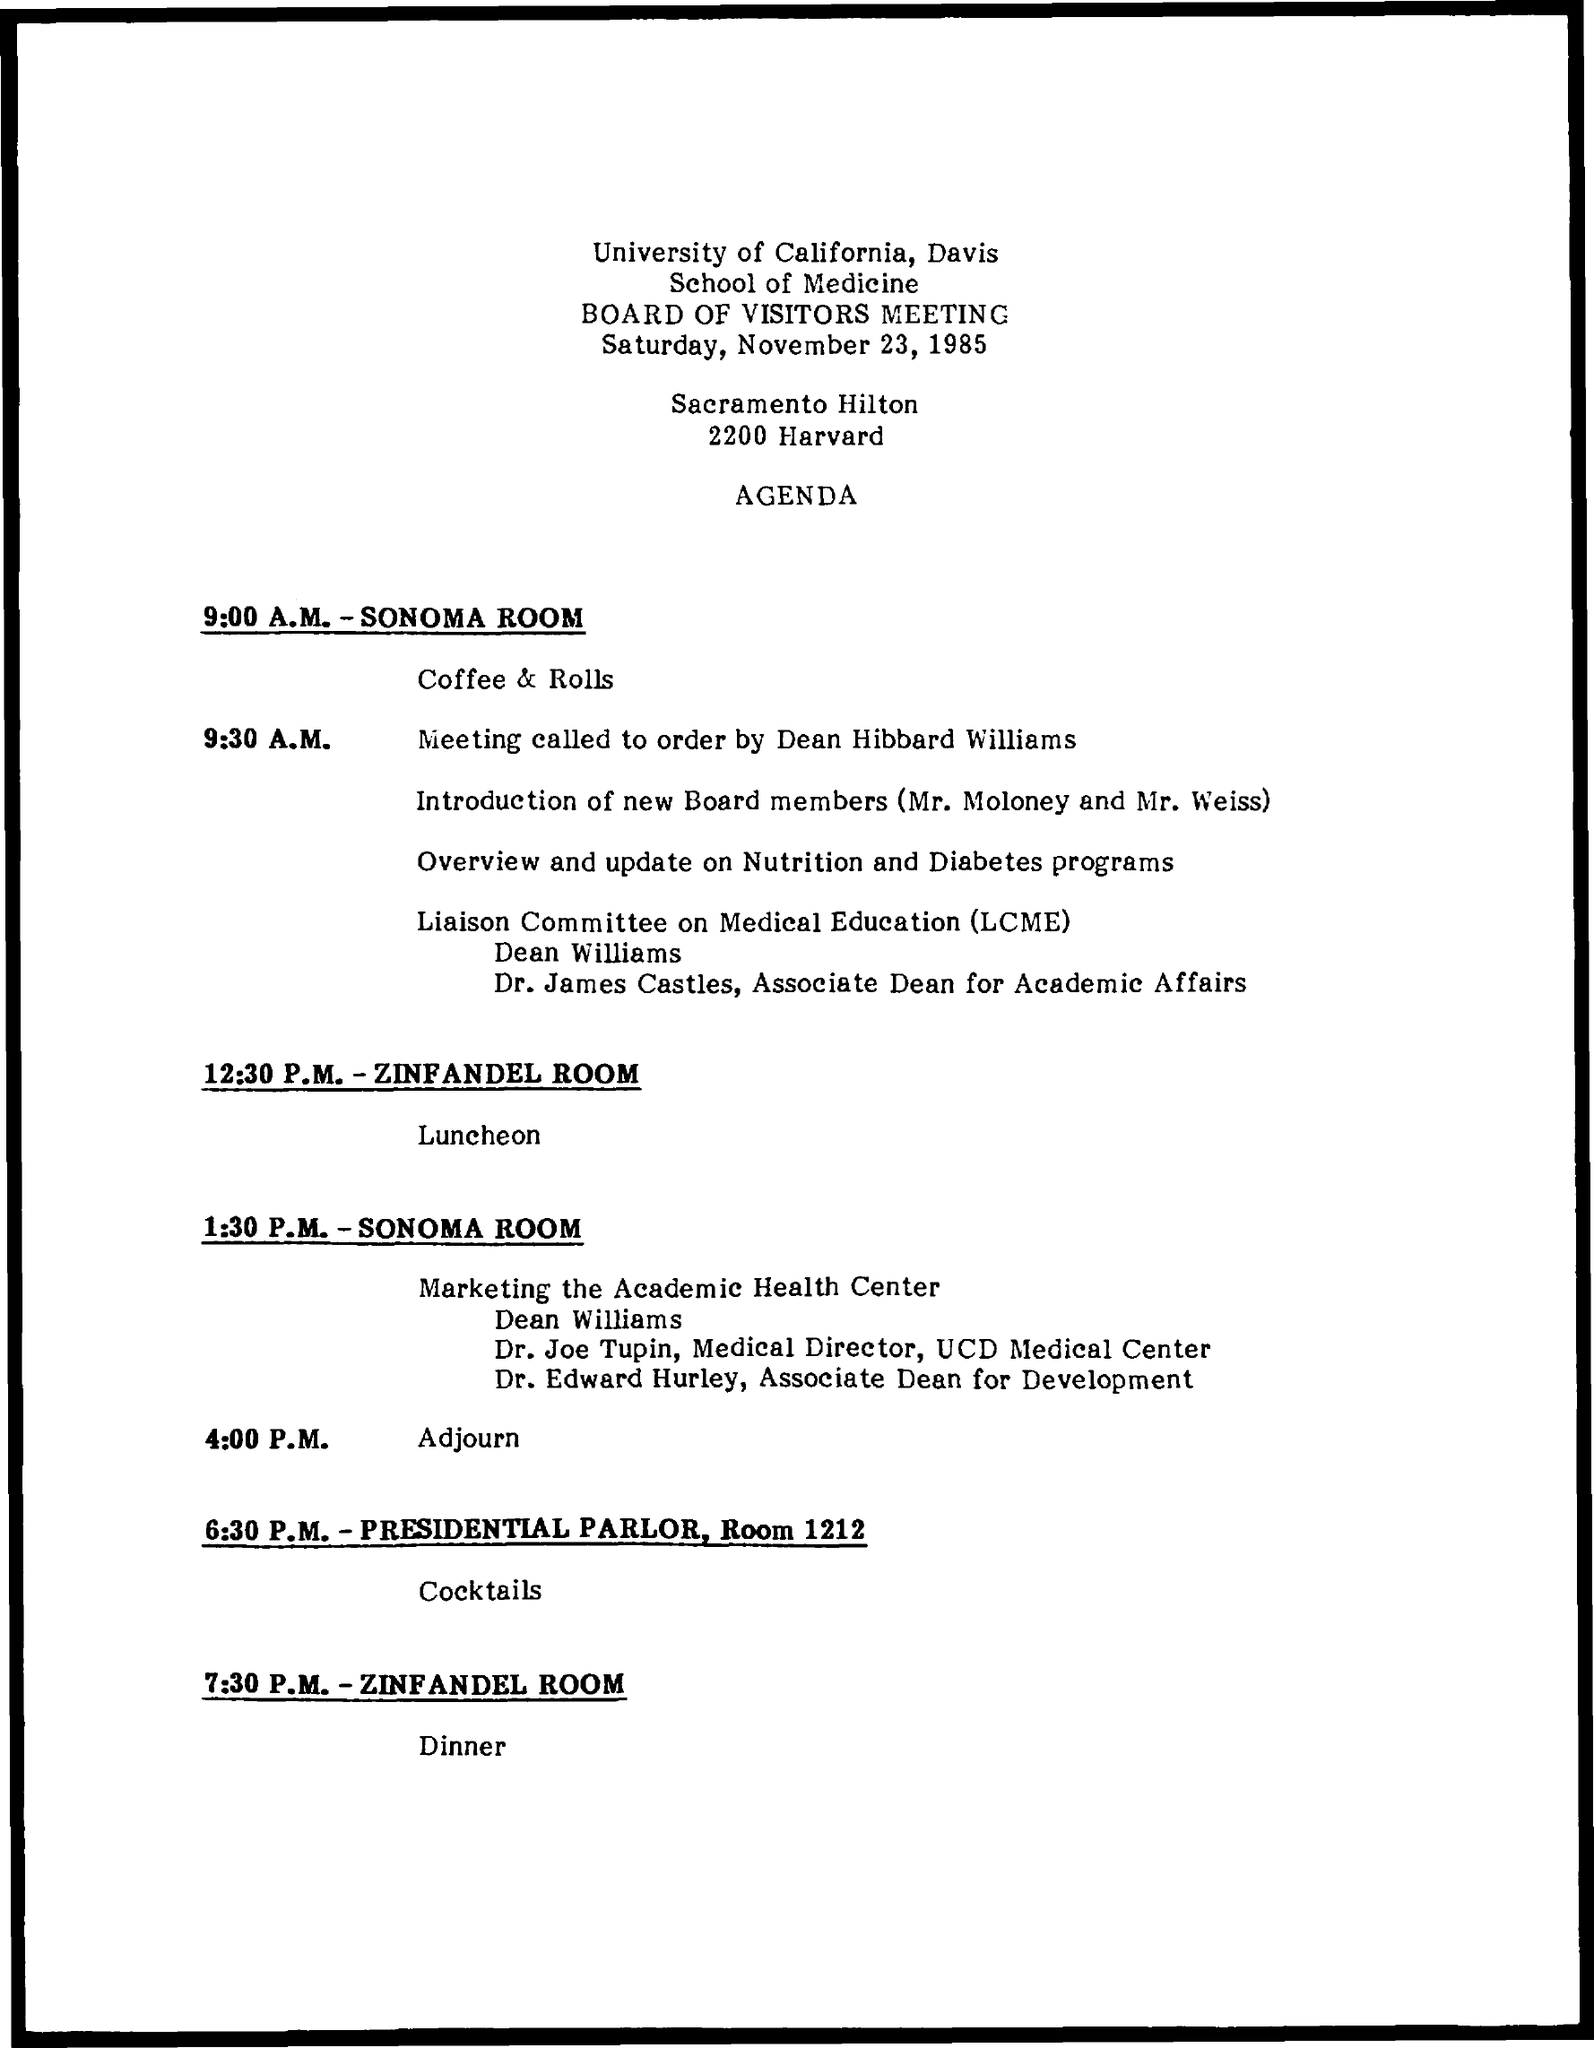Highlight a few significant elements in this photo. The full form of LCME is the Liaison Committee on Medical Education, which is a committee responsible for the accreditation of medical education programs in the United States and Canada. The date of the Board of Visitors meeting is Saturday, November 23, 1985. 